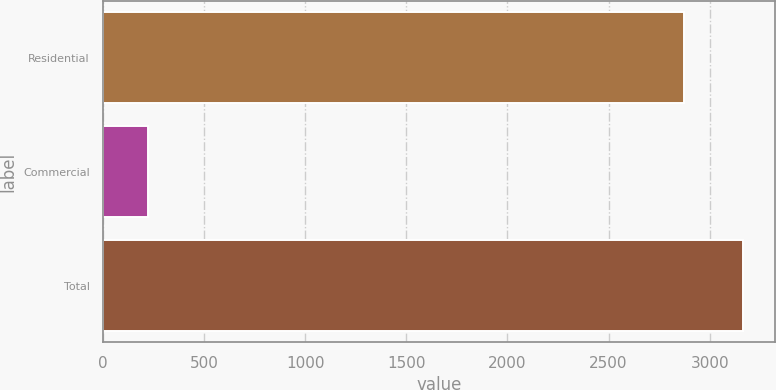Convert chart. <chart><loc_0><loc_0><loc_500><loc_500><bar_chart><fcel>Residential<fcel>Commercial<fcel>Total<nl><fcel>2872<fcel>221<fcel>3165.9<nl></chart> 